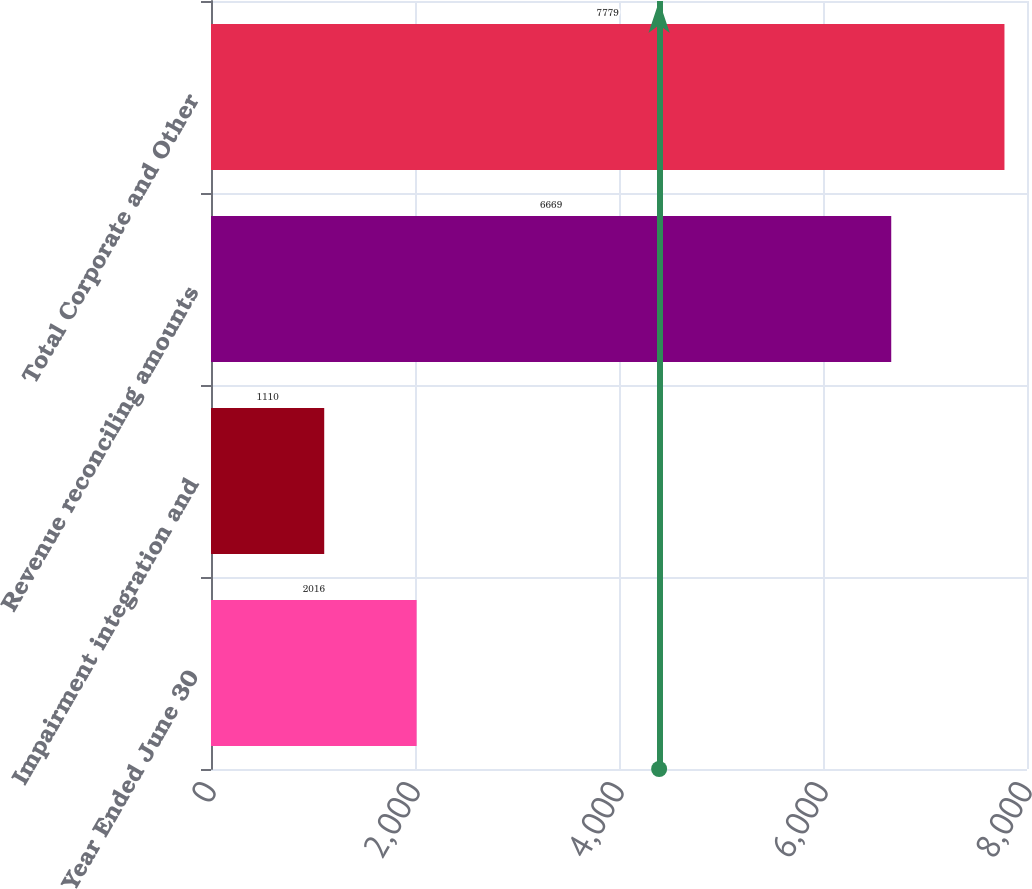Convert chart. <chart><loc_0><loc_0><loc_500><loc_500><bar_chart><fcel>Year Ended June 30<fcel>Impairment integration and<fcel>Revenue reconciling amounts<fcel>Total Corporate and Other<nl><fcel>2016<fcel>1110<fcel>6669<fcel>7779<nl></chart> 